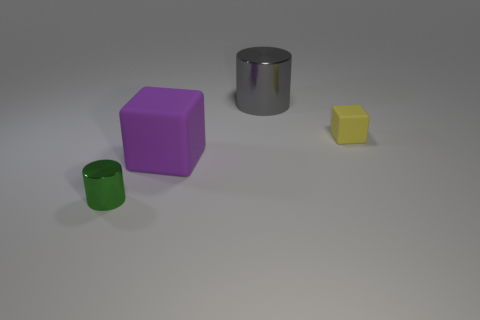Is the material of the tiny cube the same as the gray cylinder behind the green shiny thing?
Offer a very short reply. No. Are there any large purple things in front of the block on the right side of the big gray shiny object?
Ensure brevity in your answer.  Yes. What is the color of the object that is on the right side of the large purple matte object and in front of the large cylinder?
Provide a succinct answer. Yellow. What is the size of the gray metal thing?
Ensure brevity in your answer.  Large. What number of purple matte blocks are the same size as the gray object?
Your answer should be very brief. 1. Is the material of the cylinder to the right of the large purple cube the same as the cube that is to the right of the purple matte cube?
Provide a succinct answer. No. What is the material of the small object on the left side of the matte block that is right of the large block?
Ensure brevity in your answer.  Metal. What is the material of the small object on the right side of the small green metallic cylinder?
Ensure brevity in your answer.  Rubber. How many big things are the same shape as the small shiny thing?
Give a very brief answer. 1. Is the color of the tiny rubber cube the same as the large cube?
Offer a very short reply. No. 